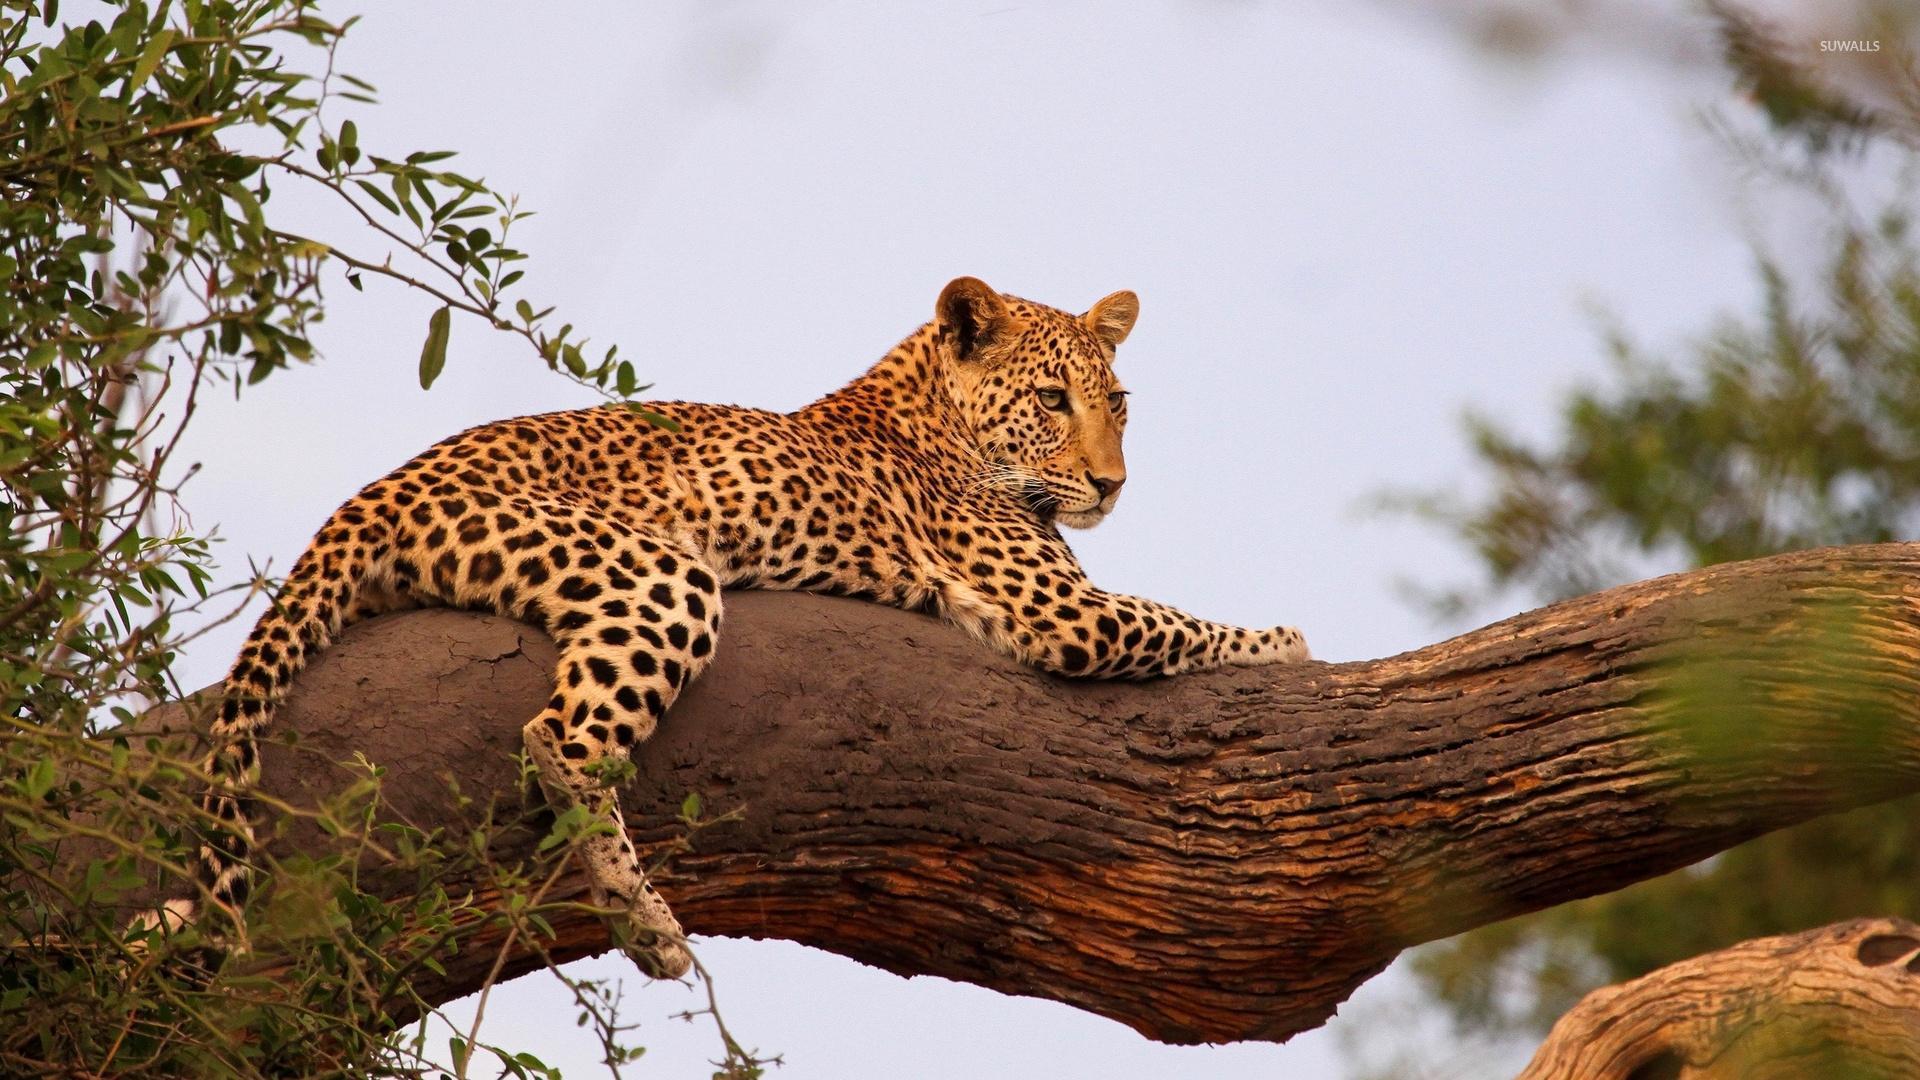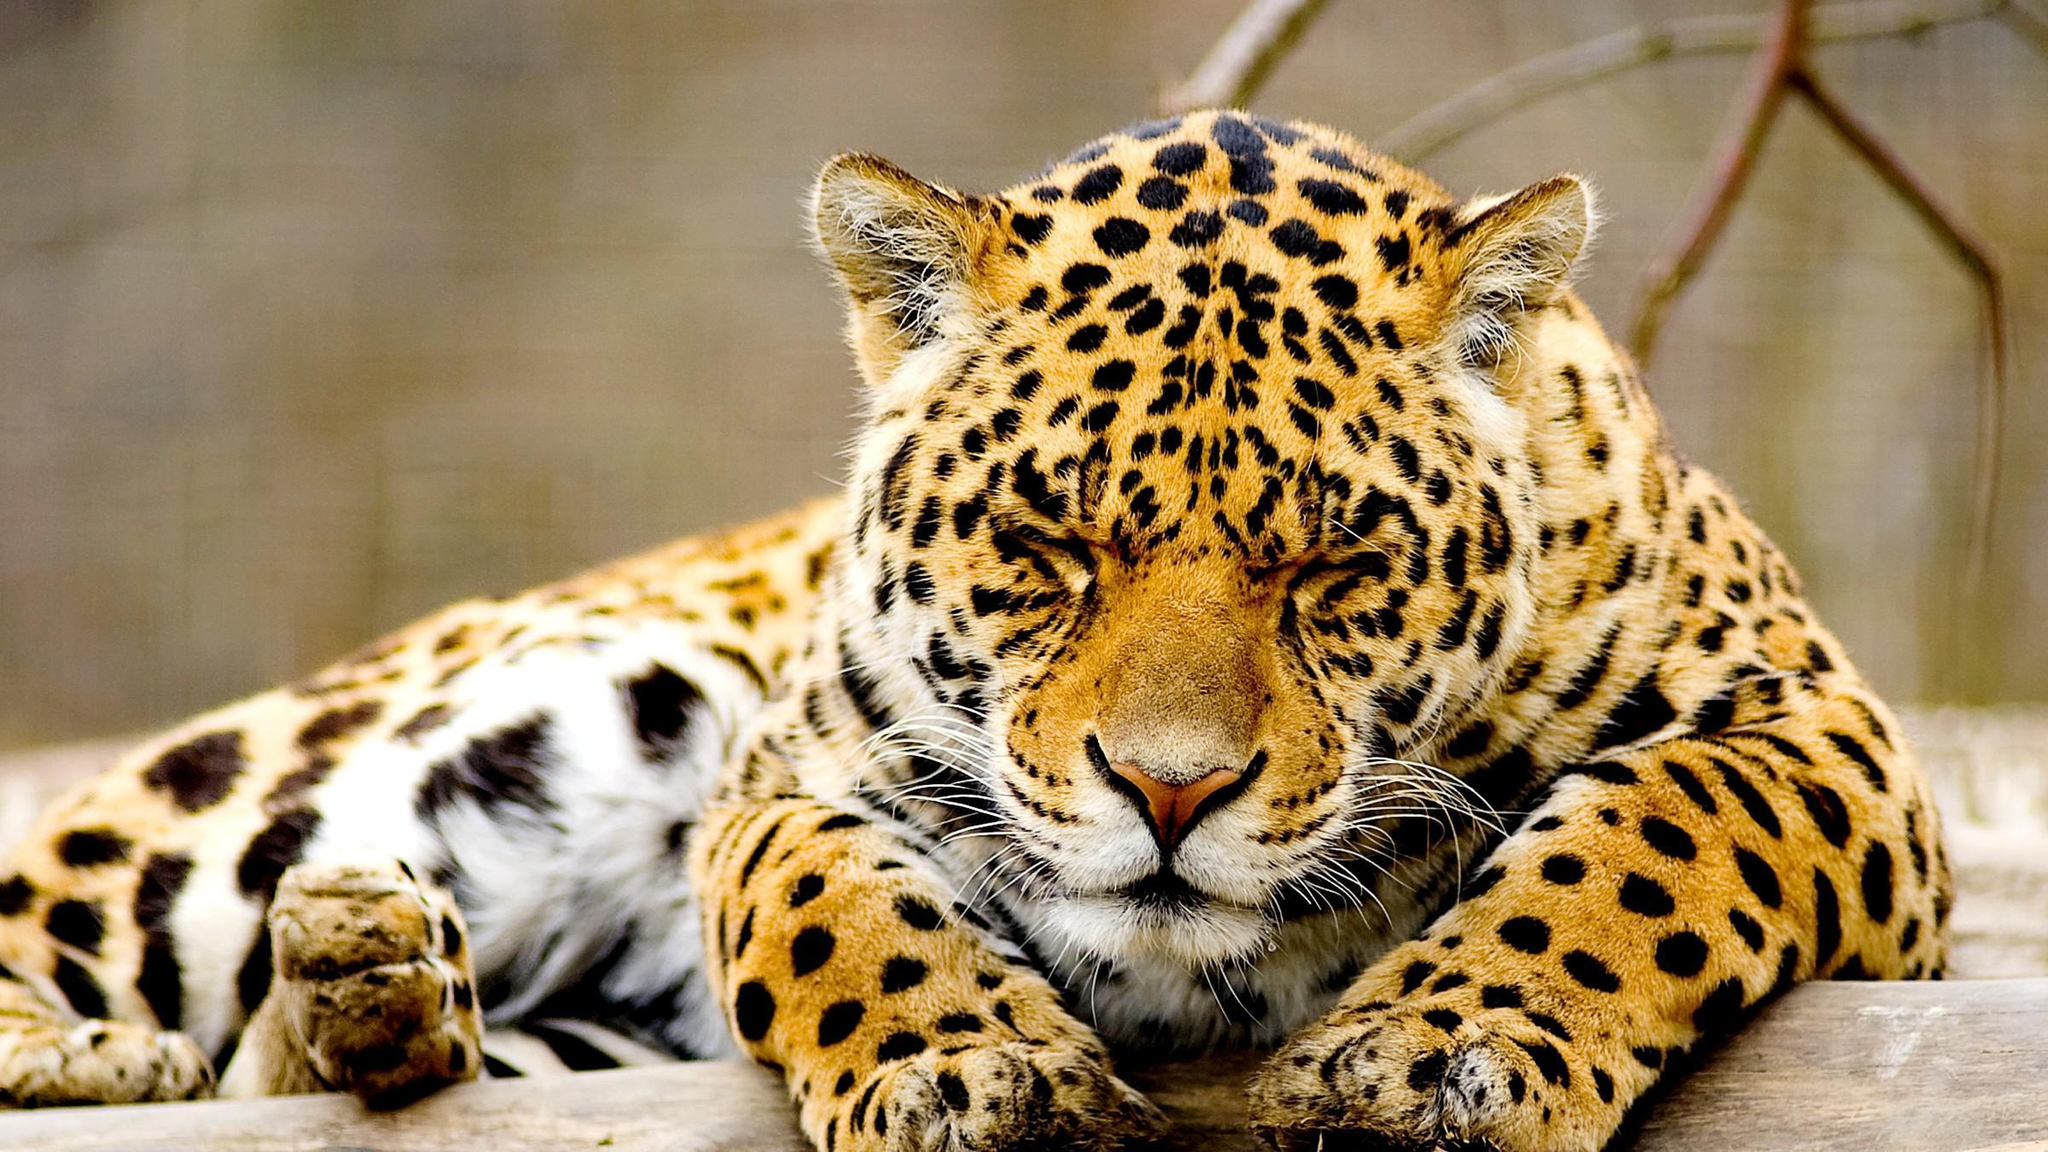The first image is the image on the left, the second image is the image on the right. Given the left and right images, does the statement "In at least one image there is a spotted leopard sleeping with his head on a large branch hiding their second ear." hold true? Answer yes or no. No. The first image is the image on the left, the second image is the image on the right. Evaluate the accuracy of this statement regarding the images: "Only one of the two leopards is asleep, and neither is showing its tongue.". Is it true? Answer yes or no. Yes. 